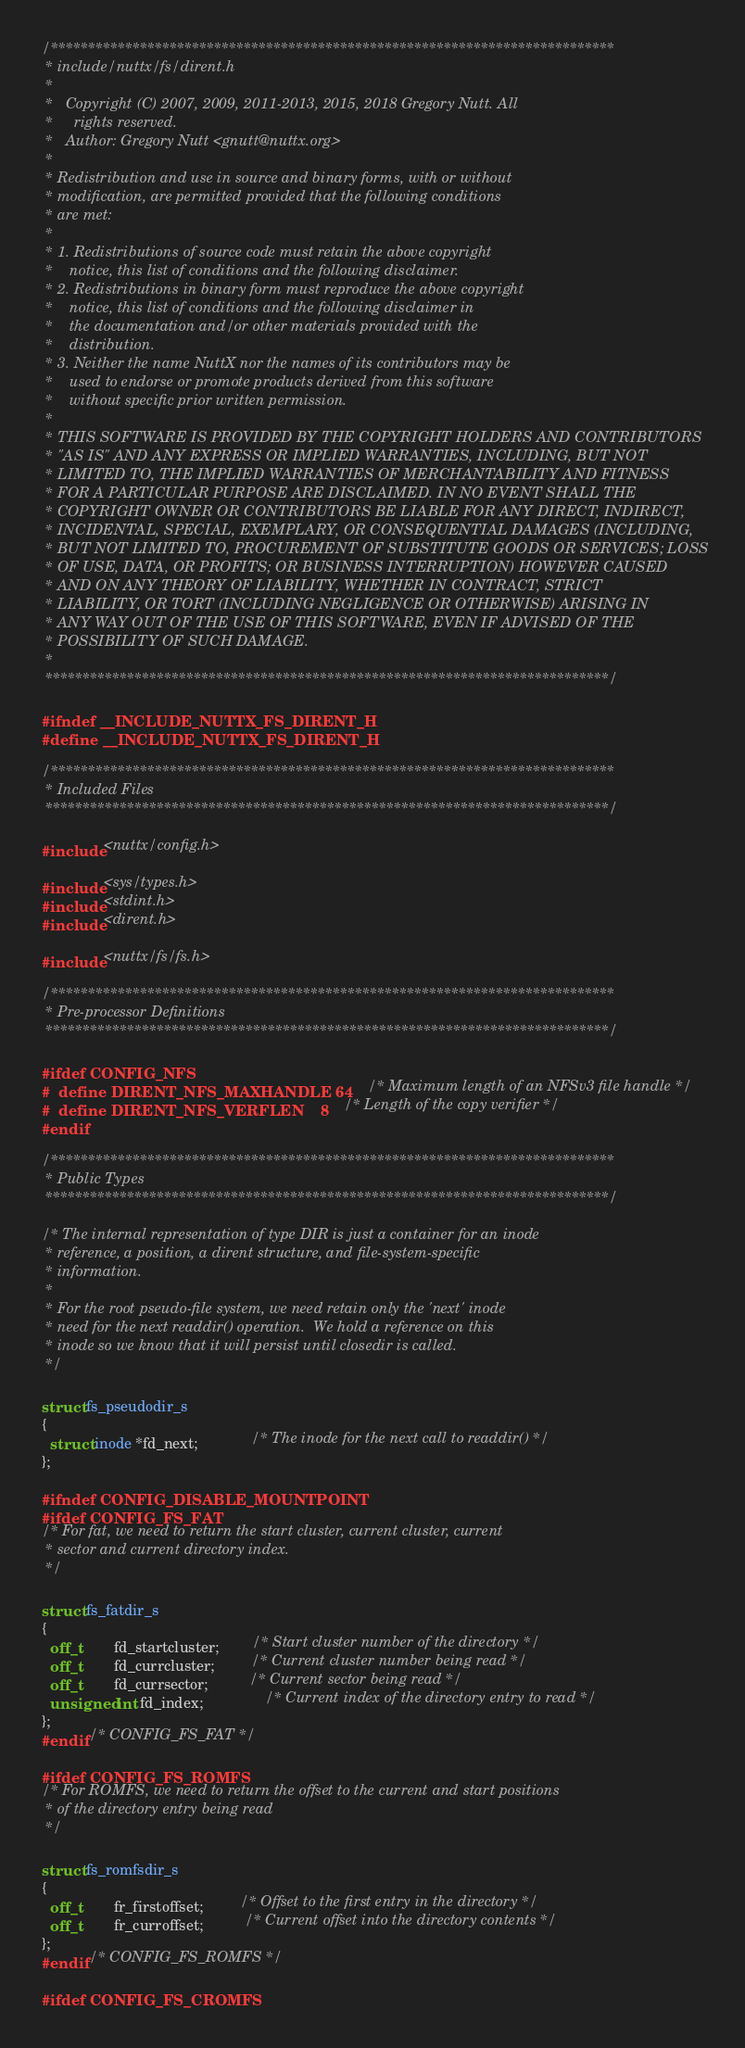Convert code to text. <code><loc_0><loc_0><loc_500><loc_500><_C_>/****************************************************************************
 * include/nuttx/fs/dirent.h
 *
 *   Copyright (C) 2007, 2009, 2011-2013, 2015, 2018 Gregory Nutt. All
 *     rights reserved.
 *   Author: Gregory Nutt <gnutt@nuttx.org>
 *
 * Redistribution and use in source and binary forms, with or without
 * modification, are permitted provided that the following conditions
 * are met:
 *
 * 1. Redistributions of source code must retain the above copyright
 *    notice, this list of conditions and the following disclaimer.
 * 2. Redistributions in binary form must reproduce the above copyright
 *    notice, this list of conditions and the following disclaimer in
 *    the documentation and/or other materials provided with the
 *    distribution.
 * 3. Neither the name NuttX nor the names of its contributors may be
 *    used to endorse or promote products derived from this software
 *    without specific prior written permission.
 *
 * THIS SOFTWARE IS PROVIDED BY THE COPYRIGHT HOLDERS AND CONTRIBUTORS
 * "AS IS" AND ANY EXPRESS OR IMPLIED WARRANTIES, INCLUDING, BUT NOT
 * LIMITED TO, THE IMPLIED WARRANTIES OF MERCHANTABILITY AND FITNESS
 * FOR A PARTICULAR PURPOSE ARE DISCLAIMED. IN NO EVENT SHALL THE
 * COPYRIGHT OWNER OR CONTRIBUTORS BE LIABLE FOR ANY DIRECT, INDIRECT,
 * INCIDENTAL, SPECIAL, EXEMPLARY, OR CONSEQUENTIAL DAMAGES (INCLUDING,
 * BUT NOT LIMITED TO, PROCUREMENT OF SUBSTITUTE GOODS OR SERVICES; LOSS
 * OF USE, DATA, OR PROFITS; OR BUSINESS INTERRUPTION) HOWEVER CAUSED
 * AND ON ANY THEORY OF LIABILITY, WHETHER IN CONTRACT, STRICT
 * LIABILITY, OR TORT (INCLUDING NEGLIGENCE OR OTHERWISE) ARISING IN
 * ANY WAY OUT OF THE USE OF THIS SOFTWARE, EVEN IF ADVISED OF THE
 * POSSIBILITY OF SUCH DAMAGE.
 *
 ****************************************************************************/

#ifndef __INCLUDE_NUTTX_FS_DIRENT_H
#define __INCLUDE_NUTTX_FS_DIRENT_H

/****************************************************************************
 * Included Files
 ****************************************************************************/

#include <nuttx/config.h>

#include <sys/types.h>
#include <stdint.h>
#include <dirent.h>

#include <nuttx/fs/fs.h>

/****************************************************************************
 * Pre-processor Definitions
 ****************************************************************************/

#ifdef CONFIG_NFS
#  define DIRENT_NFS_MAXHANDLE 64        /* Maximum length of an NFSv3 file handle */
#  define DIRENT_NFS_VERFLEN    8        /* Length of the copy verifier */
#endif

/****************************************************************************
 * Public Types
 ****************************************************************************/

/* The internal representation of type DIR is just a container for an inode
 * reference, a position, a dirent structure, and file-system-specific
 * information.
 *
 * For the root pseudo-file system, we need retain only the 'next' inode
 * need for the next readdir() operation.  We hold a reference on this
 * inode so we know that it will persist until closedir is called.
 */

struct fs_pseudodir_s
{
  struct inode *fd_next;             /* The inode for the next call to readdir() */
};

#ifndef CONFIG_DISABLE_MOUNTPOINT
#ifdef CONFIG_FS_FAT
/* For fat, we need to return the start cluster, current cluster, current
 * sector and current directory index.
 */

struct fs_fatdir_s
{
  off_t        fd_startcluster;        /* Start cluster number of the directory */
  off_t        fd_currcluster;         /* Current cluster number being read */
  off_t        fd_currsector;          /* Current sector being read */
  unsigned int fd_index;               /* Current index of the directory entry to read */
};
#endif /* CONFIG_FS_FAT */

#ifdef CONFIG_FS_ROMFS
/* For ROMFS, we need to return the offset to the current and start positions
 * of the directory entry being read
 */

struct fs_romfsdir_s
{
  off_t        fr_firstoffset;         /* Offset to the first entry in the directory */
  off_t        fr_curroffset;          /* Current offset into the directory contents */
};
#endif /* CONFIG_FS_ROMFS */

#ifdef CONFIG_FS_CROMFS</code> 